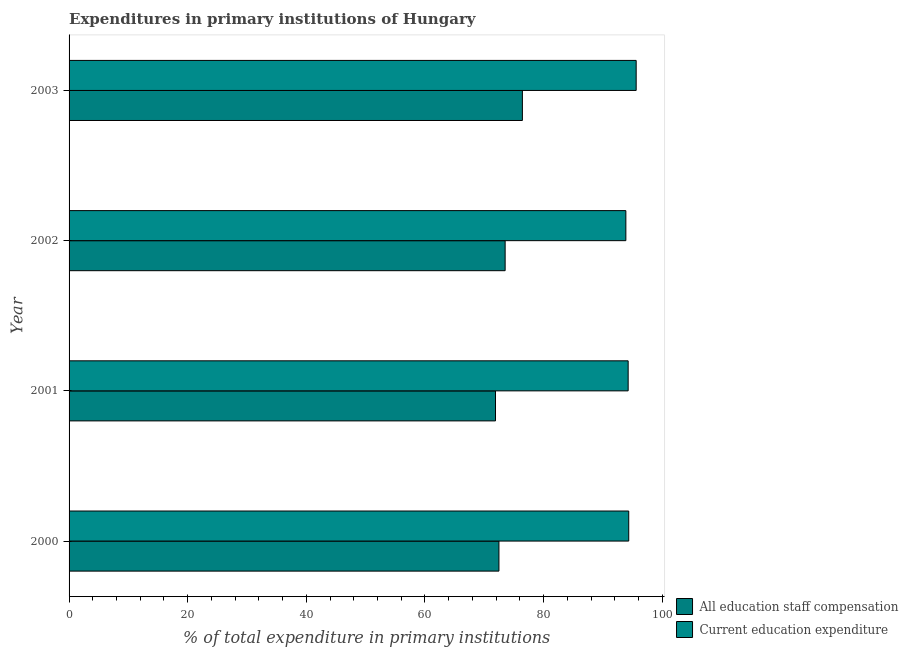How many different coloured bars are there?
Make the answer very short. 2. How many groups of bars are there?
Provide a succinct answer. 4. In how many cases, is the number of bars for a given year not equal to the number of legend labels?
Your response must be concise. 0. What is the expenditure in staff compensation in 2002?
Make the answer very short. 73.52. Across all years, what is the maximum expenditure in staff compensation?
Your answer should be compact. 76.42. Across all years, what is the minimum expenditure in education?
Give a very brief answer. 93.87. In which year was the expenditure in education maximum?
Provide a short and direct response. 2003. What is the total expenditure in education in the graph?
Give a very brief answer. 378.09. What is the difference between the expenditure in staff compensation in 2000 and that in 2002?
Offer a very short reply. -1.04. What is the difference between the expenditure in staff compensation in 2000 and the expenditure in education in 2001?
Provide a succinct answer. -21.79. What is the average expenditure in staff compensation per year?
Your response must be concise. 73.58. In the year 2000, what is the difference between the expenditure in staff compensation and expenditure in education?
Keep it short and to the point. -21.88. In how many years, is the expenditure in staff compensation greater than 24 %?
Keep it short and to the point. 4. What is the ratio of the expenditure in staff compensation in 2000 to that in 2003?
Keep it short and to the point. 0.95. What is the difference between the highest and the second highest expenditure in education?
Your answer should be very brief. 1.25. What is the difference between the highest and the lowest expenditure in education?
Your answer should be compact. 1.74. In how many years, is the expenditure in staff compensation greater than the average expenditure in staff compensation taken over all years?
Your answer should be very brief. 1. What does the 1st bar from the top in 2000 represents?
Provide a succinct answer. Current education expenditure. What does the 1st bar from the bottom in 2003 represents?
Offer a very short reply. All education staff compensation. How many bars are there?
Offer a terse response. 8. Are the values on the major ticks of X-axis written in scientific E-notation?
Your answer should be compact. No. Does the graph contain any zero values?
Offer a very short reply. No. Does the graph contain grids?
Make the answer very short. No. How many legend labels are there?
Give a very brief answer. 2. What is the title of the graph?
Make the answer very short. Expenditures in primary institutions of Hungary. What is the label or title of the X-axis?
Your answer should be very brief. % of total expenditure in primary institutions. What is the label or title of the Y-axis?
Your answer should be very brief. Year. What is the % of total expenditure in primary institutions in All education staff compensation in 2000?
Provide a succinct answer. 72.47. What is the % of total expenditure in primary institutions in Current education expenditure in 2000?
Keep it short and to the point. 94.35. What is the % of total expenditure in primary institutions of All education staff compensation in 2001?
Ensure brevity in your answer.  71.89. What is the % of total expenditure in primary institutions of Current education expenditure in 2001?
Ensure brevity in your answer.  94.26. What is the % of total expenditure in primary institutions of All education staff compensation in 2002?
Give a very brief answer. 73.52. What is the % of total expenditure in primary institutions in Current education expenditure in 2002?
Give a very brief answer. 93.87. What is the % of total expenditure in primary institutions in All education staff compensation in 2003?
Your response must be concise. 76.42. What is the % of total expenditure in primary institutions in Current education expenditure in 2003?
Provide a succinct answer. 95.61. Across all years, what is the maximum % of total expenditure in primary institutions of All education staff compensation?
Offer a very short reply. 76.42. Across all years, what is the maximum % of total expenditure in primary institutions in Current education expenditure?
Your response must be concise. 95.61. Across all years, what is the minimum % of total expenditure in primary institutions of All education staff compensation?
Provide a short and direct response. 71.89. Across all years, what is the minimum % of total expenditure in primary institutions of Current education expenditure?
Your answer should be very brief. 93.87. What is the total % of total expenditure in primary institutions of All education staff compensation in the graph?
Your answer should be compact. 294.3. What is the total % of total expenditure in primary institutions in Current education expenditure in the graph?
Keep it short and to the point. 378.09. What is the difference between the % of total expenditure in primary institutions of All education staff compensation in 2000 and that in 2001?
Offer a terse response. 0.58. What is the difference between the % of total expenditure in primary institutions of Current education expenditure in 2000 and that in 2001?
Offer a very short reply. 0.1. What is the difference between the % of total expenditure in primary institutions in All education staff compensation in 2000 and that in 2002?
Your response must be concise. -1.04. What is the difference between the % of total expenditure in primary institutions in Current education expenditure in 2000 and that in 2002?
Your answer should be compact. 0.48. What is the difference between the % of total expenditure in primary institutions of All education staff compensation in 2000 and that in 2003?
Offer a terse response. -3.95. What is the difference between the % of total expenditure in primary institutions of Current education expenditure in 2000 and that in 2003?
Your response must be concise. -1.25. What is the difference between the % of total expenditure in primary institutions of All education staff compensation in 2001 and that in 2002?
Give a very brief answer. -1.62. What is the difference between the % of total expenditure in primary institutions in Current education expenditure in 2001 and that in 2002?
Your answer should be very brief. 0.39. What is the difference between the % of total expenditure in primary institutions of All education staff compensation in 2001 and that in 2003?
Keep it short and to the point. -4.53. What is the difference between the % of total expenditure in primary institutions in Current education expenditure in 2001 and that in 2003?
Offer a very short reply. -1.35. What is the difference between the % of total expenditure in primary institutions in All education staff compensation in 2002 and that in 2003?
Keep it short and to the point. -2.91. What is the difference between the % of total expenditure in primary institutions in Current education expenditure in 2002 and that in 2003?
Provide a succinct answer. -1.74. What is the difference between the % of total expenditure in primary institutions in All education staff compensation in 2000 and the % of total expenditure in primary institutions in Current education expenditure in 2001?
Provide a short and direct response. -21.79. What is the difference between the % of total expenditure in primary institutions in All education staff compensation in 2000 and the % of total expenditure in primary institutions in Current education expenditure in 2002?
Give a very brief answer. -21.4. What is the difference between the % of total expenditure in primary institutions in All education staff compensation in 2000 and the % of total expenditure in primary institutions in Current education expenditure in 2003?
Your response must be concise. -23.14. What is the difference between the % of total expenditure in primary institutions in All education staff compensation in 2001 and the % of total expenditure in primary institutions in Current education expenditure in 2002?
Offer a very short reply. -21.98. What is the difference between the % of total expenditure in primary institutions in All education staff compensation in 2001 and the % of total expenditure in primary institutions in Current education expenditure in 2003?
Offer a very short reply. -23.72. What is the difference between the % of total expenditure in primary institutions in All education staff compensation in 2002 and the % of total expenditure in primary institutions in Current education expenditure in 2003?
Your answer should be compact. -22.09. What is the average % of total expenditure in primary institutions in All education staff compensation per year?
Ensure brevity in your answer.  73.58. What is the average % of total expenditure in primary institutions in Current education expenditure per year?
Offer a terse response. 94.52. In the year 2000, what is the difference between the % of total expenditure in primary institutions of All education staff compensation and % of total expenditure in primary institutions of Current education expenditure?
Your answer should be very brief. -21.88. In the year 2001, what is the difference between the % of total expenditure in primary institutions of All education staff compensation and % of total expenditure in primary institutions of Current education expenditure?
Give a very brief answer. -22.37. In the year 2002, what is the difference between the % of total expenditure in primary institutions of All education staff compensation and % of total expenditure in primary institutions of Current education expenditure?
Your answer should be very brief. -20.35. In the year 2003, what is the difference between the % of total expenditure in primary institutions in All education staff compensation and % of total expenditure in primary institutions in Current education expenditure?
Your response must be concise. -19.18. What is the ratio of the % of total expenditure in primary institutions of All education staff compensation in 2000 to that in 2001?
Your response must be concise. 1.01. What is the ratio of the % of total expenditure in primary institutions of All education staff compensation in 2000 to that in 2002?
Offer a very short reply. 0.99. What is the ratio of the % of total expenditure in primary institutions of Current education expenditure in 2000 to that in 2002?
Give a very brief answer. 1.01. What is the ratio of the % of total expenditure in primary institutions in All education staff compensation in 2000 to that in 2003?
Your answer should be compact. 0.95. What is the ratio of the % of total expenditure in primary institutions in Current education expenditure in 2000 to that in 2003?
Your answer should be very brief. 0.99. What is the ratio of the % of total expenditure in primary institutions of All education staff compensation in 2001 to that in 2002?
Give a very brief answer. 0.98. What is the ratio of the % of total expenditure in primary institutions in All education staff compensation in 2001 to that in 2003?
Keep it short and to the point. 0.94. What is the ratio of the % of total expenditure in primary institutions in Current education expenditure in 2001 to that in 2003?
Make the answer very short. 0.99. What is the ratio of the % of total expenditure in primary institutions in All education staff compensation in 2002 to that in 2003?
Give a very brief answer. 0.96. What is the ratio of the % of total expenditure in primary institutions of Current education expenditure in 2002 to that in 2003?
Your answer should be compact. 0.98. What is the difference between the highest and the second highest % of total expenditure in primary institutions of All education staff compensation?
Your answer should be compact. 2.91. What is the difference between the highest and the second highest % of total expenditure in primary institutions in Current education expenditure?
Provide a succinct answer. 1.25. What is the difference between the highest and the lowest % of total expenditure in primary institutions in All education staff compensation?
Provide a short and direct response. 4.53. What is the difference between the highest and the lowest % of total expenditure in primary institutions in Current education expenditure?
Make the answer very short. 1.74. 